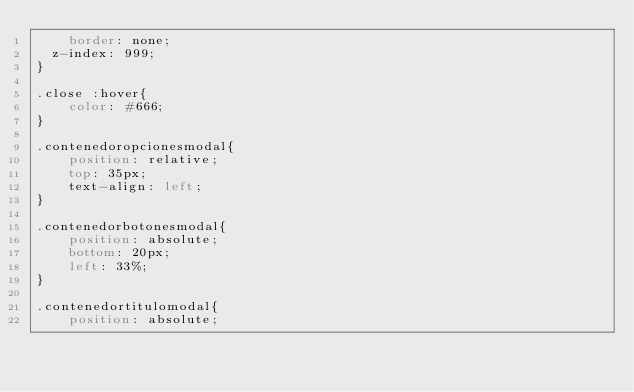Convert code to text. <code><loc_0><loc_0><loc_500><loc_500><_CSS_>    border: none;
	z-index: 999;
}

.close :hover{
    color: #666;
}

.contenedoropcionesmodal{
    position: relative;
    top: 35px;
    text-align: left;
}

.contenedorbotonesmodal{
    position: absolute;
    bottom: 20px;
    left: 33%;
}

.contenedortitulomodal{
    position: absolute;</code> 